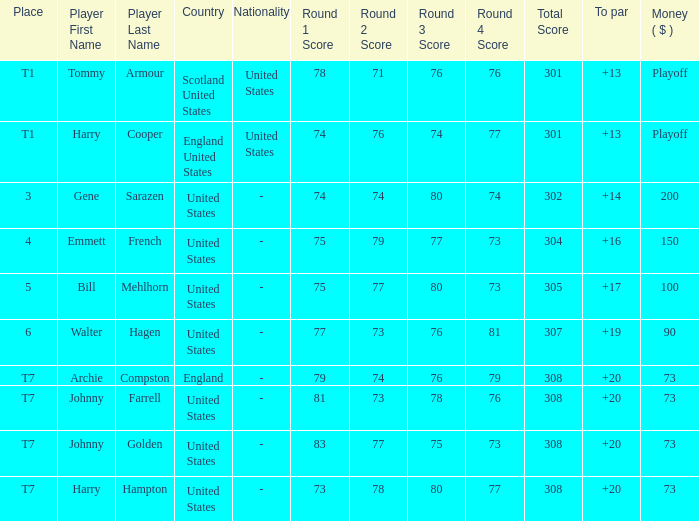Which country has a to par less than 19 and a score of 75-79-77-73=304? United States. 